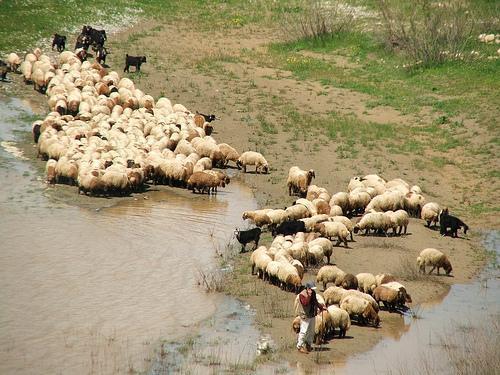How many people are guiding the sheep?
Give a very brief answer. 1. How many trains are in the picture?
Give a very brief answer. 0. 